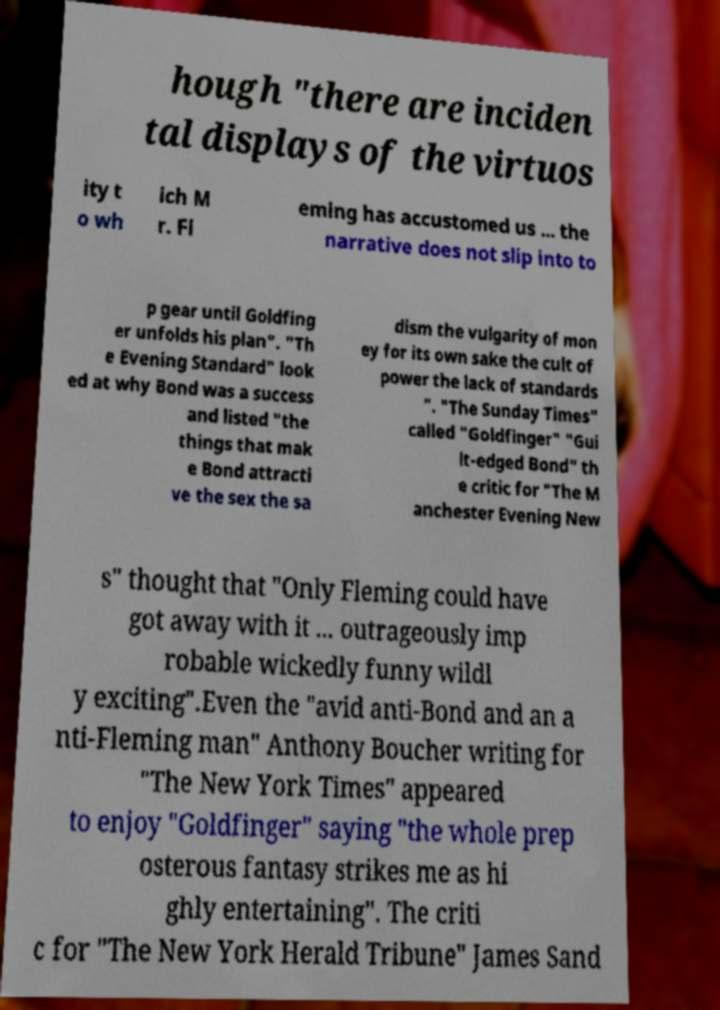Can you read and provide the text displayed in the image?This photo seems to have some interesting text. Can you extract and type it out for me? hough "there are inciden tal displays of the virtuos ity t o wh ich M r. Fl eming has accustomed us ... the narrative does not slip into to p gear until Goldfing er unfolds his plan". "Th e Evening Standard" look ed at why Bond was a success and listed "the things that mak e Bond attracti ve the sex the sa dism the vulgarity of mon ey for its own sake the cult of power the lack of standards ". "The Sunday Times" called "Goldfinger" "Gui lt-edged Bond" th e critic for "The M anchester Evening New s" thought that "Only Fleming could have got away with it ... outrageously imp robable wickedly funny wildl y exciting".Even the "avid anti-Bond and an a nti-Fleming man" Anthony Boucher writing for "The New York Times" appeared to enjoy "Goldfinger" saying "the whole prep osterous fantasy strikes me as hi ghly entertaining". The criti c for "The New York Herald Tribune" James Sand 